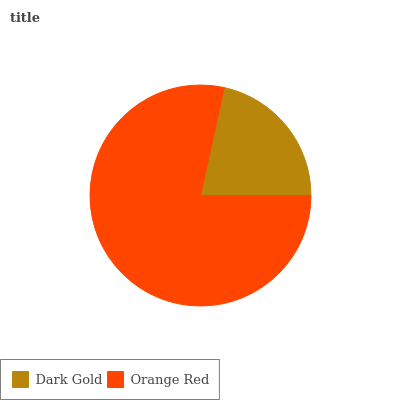Is Dark Gold the minimum?
Answer yes or no. Yes. Is Orange Red the maximum?
Answer yes or no. Yes. Is Orange Red the minimum?
Answer yes or no. No. Is Orange Red greater than Dark Gold?
Answer yes or no. Yes. Is Dark Gold less than Orange Red?
Answer yes or no. Yes. Is Dark Gold greater than Orange Red?
Answer yes or no. No. Is Orange Red less than Dark Gold?
Answer yes or no. No. Is Orange Red the high median?
Answer yes or no. Yes. Is Dark Gold the low median?
Answer yes or no. Yes. Is Dark Gold the high median?
Answer yes or no. No. Is Orange Red the low median?
Answer yes or no. No. 